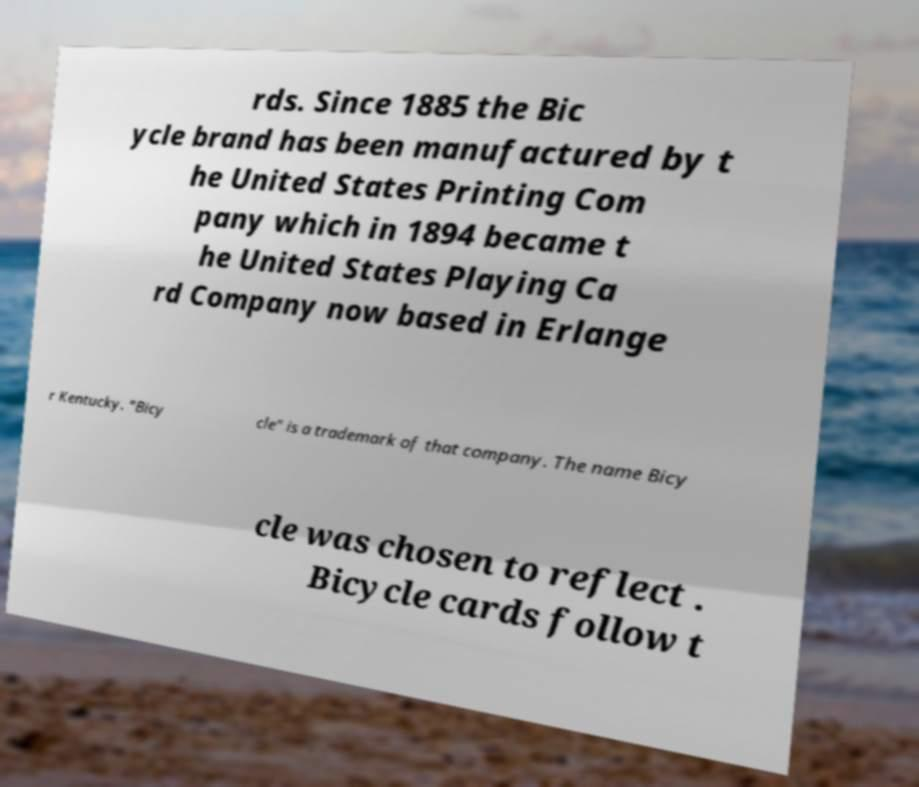I need the written content from this picture converted into text. Can you do that? rds. Since 1885 the Bic ycle brand has been manufactured by t he United States Printing Com pany which in 1894 became t he United States Playing Ca rd Company now based in Erlange r Kentucky. "Bicy cle" is a trademark of that company. The name Bicy cle was chosen to reflect . Bicycle cards follow t 